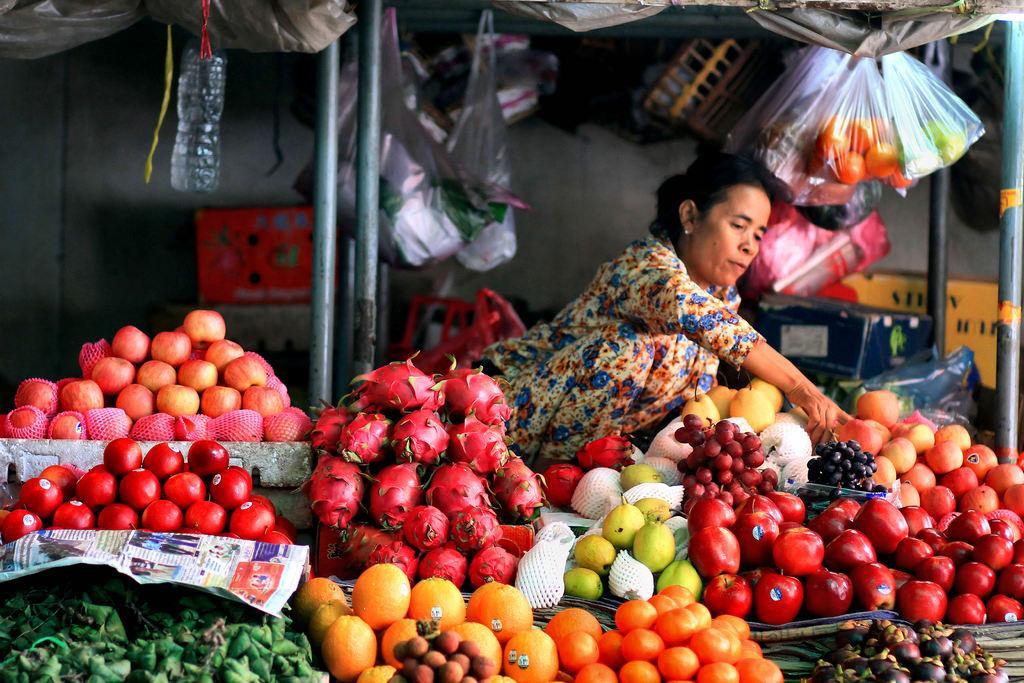In one or two sentences, can you explain what this image depicts? In the picture we can see a fruit shop with fruits on the desk and behind it, we can see a woman standing and arranging the fruits and beside her we can see some poles and to the ceiling we can see some polythene bags and into the wall we can see a some red color box to it. 